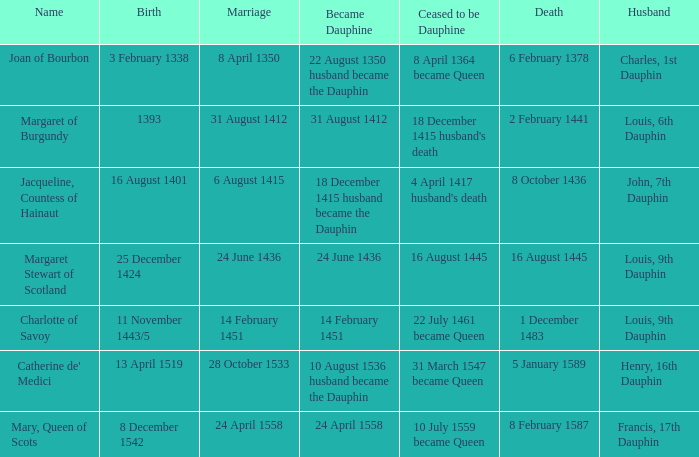When was the passing of the individual with partner charles, 1st dauphin? 6 February 1378. 